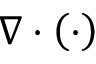<formula> <loc_0><loc_0><loc_500><loc_500>\nabla \cdot \left ( \cdot \right )</formula> 